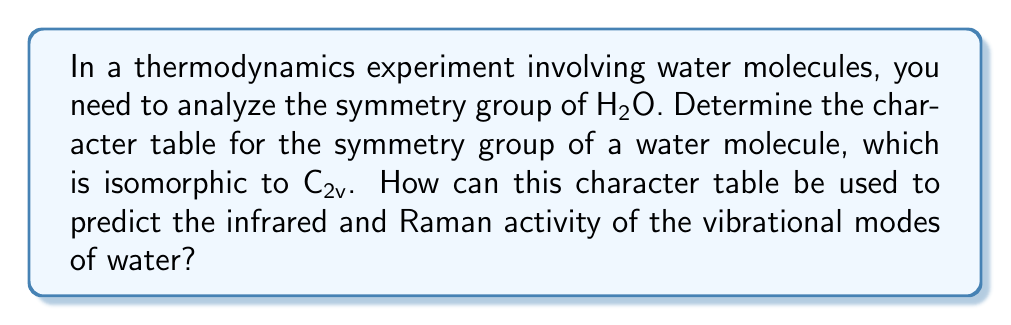Teach me how to tackle this problem. Let's approach this step-by-step:

1) First, we need to identify the symmetry operations of the water molecule:
   - E (identity)
   - C2 (180° rotation around the z-axis)
   - σv(xz) (reflection in the xz-plane)
   - σ'v(yz) (reflection in the yz-plane)

2) The C2v group has four irreducible representations: A1, A2, B1, and B2.

3) We can now construct the character table:

   $$\begin{array}{c|cccc}
   \text{C2v} & E & C_2 & \sigma_v(xz) & \sigma'_v(yz) \\
   \hline
   A_1 & 1 & 1 & 1 & 1 \\
   A_2 & 1 & 1 & -1 & -1 \\
   B_1 & 1 & -1 & 1 & -1 \\
   B_2 & 1 & -1 & -1 & 1
   \end{array}$$

4) To determine the infrared and Raman activity:
   - Infrared active modes transform like x, y, or z
   - Raman active modes transform like x², y², z², xy, xz, or yz

5) We can add this information to our character table:

   $$\begin{array}{c|cccc|c}
   \text{C2v} & E & C_2 & \sigma_v(xz) & \sigma'_v(yz) & \\
   \hline
   A_1 & 1 & 1 & 1 & 1 & z, x^2, y^2, z^2 \\
   A_2 & 1 & 1 & -1 & -1 & R_z, xy \\
   B_1 & 1 & -1 & 1 & -1 & x, R_y, xz \\
   B_2 & 1 & -1 & -1 & 1 & y, R_x, yz
   \end{array}$$

6) From this, we can conclude:
   - A1, B1, and B2 modes are both infrared and Raman active
   - A2 modes are only Raman active

This character table allows us to predict the activity of vibrational modes in spectroscopic experiments, which is crucial for analyzing the thermodynamic properties of water in various states.
Answer: Character table for C2v; A1, B1, B2 IR and Raman active; A2 only Raman active. 